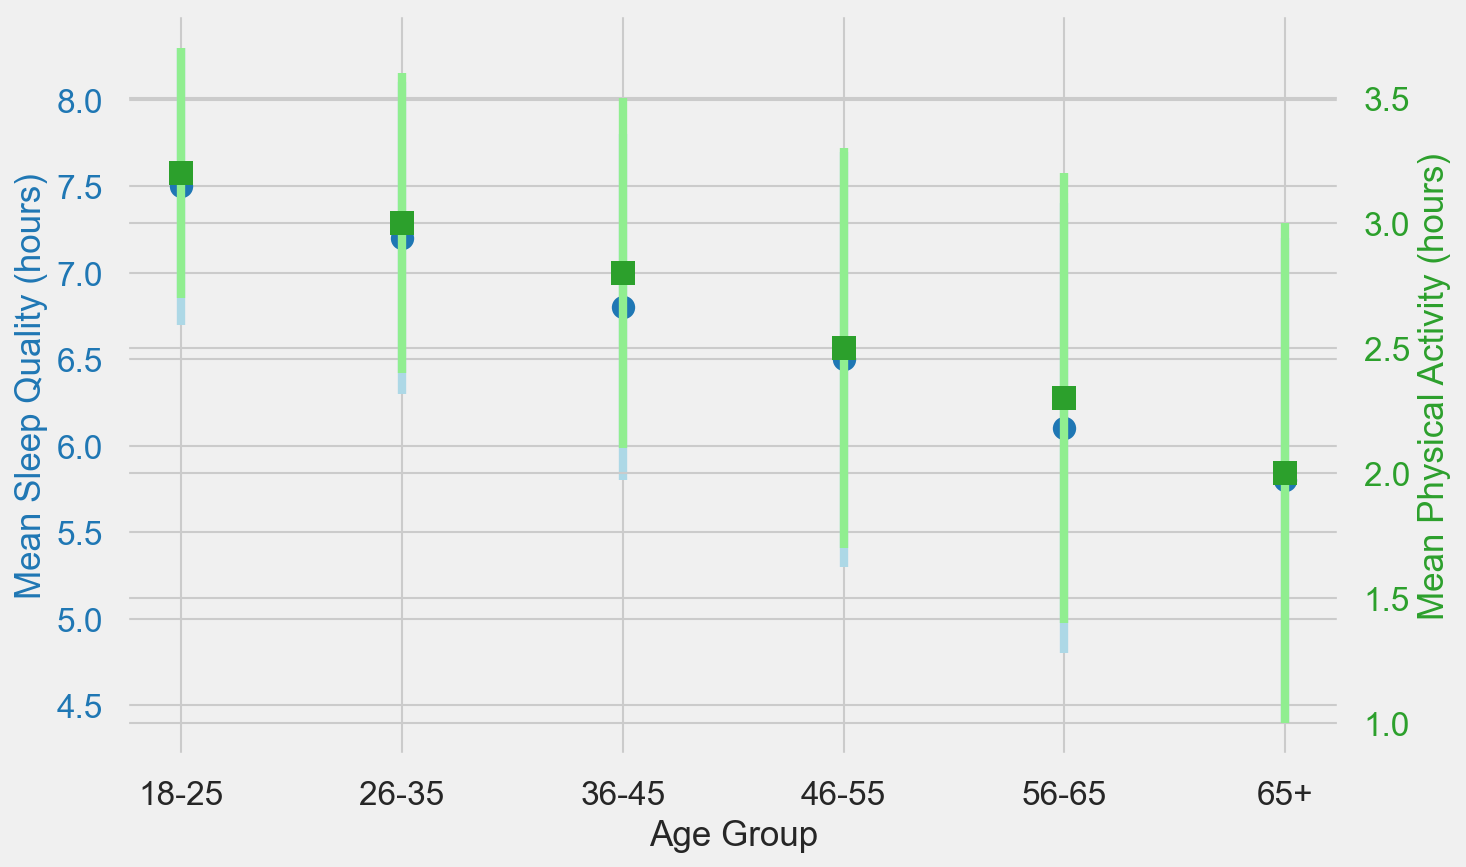What age group has the highest mean sleep quality? The chart shows that the age group 18-25 has the highest mean sleep quality with 7.5 hours, indicated by the blue dots.
Answer: 18-25 Which age group has the lowest mean physical activity? The chart shows that the 65+ age group has the lowest mean physical activity with 2.0 hours, indicated by the green squares.
Answer: 65+ What is the difference in mean sleep quality between the 18-25 and 65+ age groups? The mean sleep quality for the 18-25 age group is 7.5 hours, and for the 65+ age group, it is 5.8 hours. The difference is 7.5 - 5.8 = 1.7 hours.
Answer: 1.7 hours Which age group shows the largest standard deviation in physical activity levels? By observing the error bars for physical activity levels, the 65+ age group has the largest standard deviation in physical activity with a value of 1.0 hours.
Answer: 65+ Compare mean sleep quality and mean physical activity levels of the 36-45 age group. For the 36-45 age group, the mean sleep quality is 6.8 hours and the mean physical activity is 2.8 hours. Both are read off the corresponding plots.
Answer: Mean sleep quality: 6.8 hours, mean physical activity: 2.8 hours What age group has a mean sleep quality of less than 7 hours? The age groups 36-45, 46-55, 56-65, and 65+ all have mean sleep quality below 7 hours as indicated by the blue dots falling below 7 on the sleep quality axis.
Answer: 36-45, 46-55, 56-65, 65+ Is there an age group where the standard deviation of sleep quality is greater than 1 hour? The age groups 46-55, 56-65, and 65+ all have standard deviations in sleep quality greater than 1 hour as indicated by the size of their error bars.
Answer: 46-55, 56-65, 65+ What is the trend of mean sleep quality as age increases? Observing the trend of the blue dots, mean sleep quality decreases as age increases from 18-25 to 65+.
Answer: Decreases What is the error bar range for mean physical activity in the 26-35 age group? For the 26-35 age group, the mean physical activity is 3.0 hours, with a standard deviation of 0.6 hours. The error bar range is thus 3.0 ± 0.6 (2.4 to 3.6 hours).
Answer: 2.4 to 3.6 hours Does an increase in age generally correlate with lesser physical activity? By observing the green squares, physical activity decreases as age increases from 18-25 to 65+, indicating a negative correlation.
Answer: Yes 